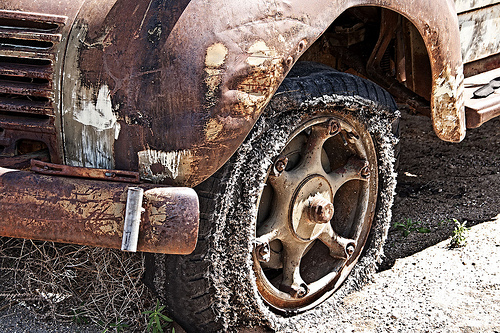<image>
Can you confirm if the bumper is in the wheel? No. The bumper is not contained within the wheel. These objects have a different spatial relationship. 